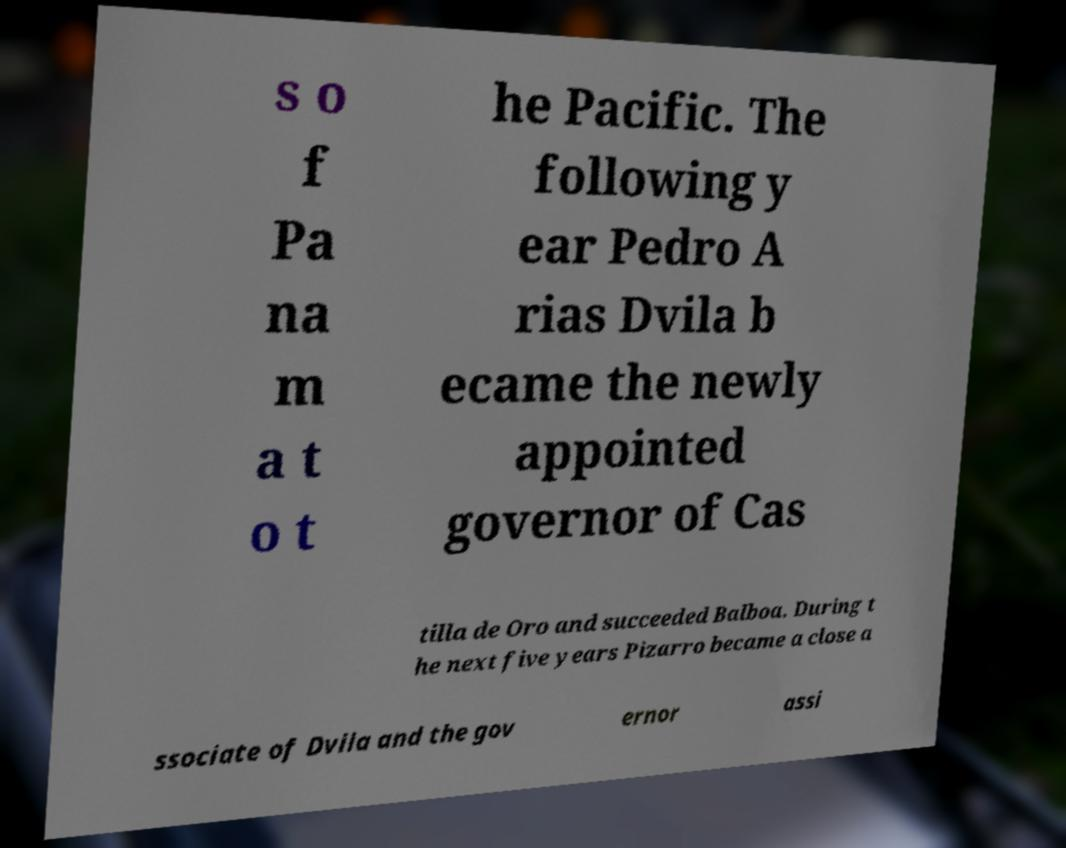Can you accurately transcribe the text from the provided image for me? s o f Pa na m a t o t he Pacific. The following y ear Pedro A rias Dvila b ecame the newly appointed governor of Cas tilla de Oro and succeeded Balboa. During t he next five years Pizarro became a close a ssociate of Dvila and the gov ernor assi 